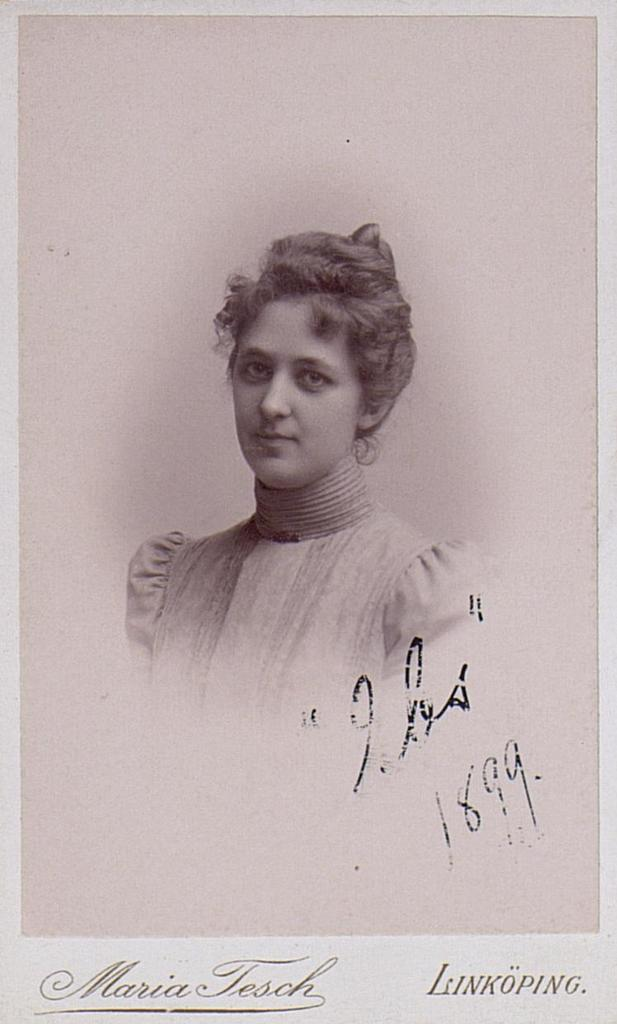What is the main subject of the image? There is a photo of a woman in the image. What additional elements are present on the photo? There are words and numbers on the photo. How does the woman run in the image? The image is a photo of a woman, and there is no action or movement depicted, so the woman is not running in the image. 